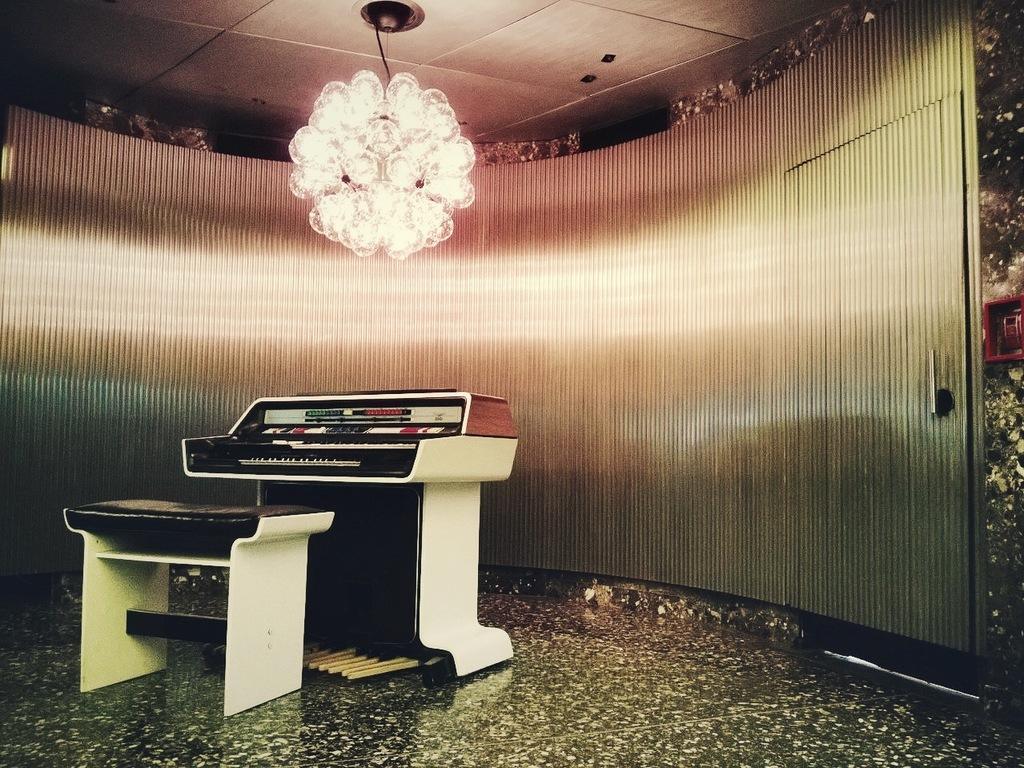How would you summarize this image in a sentence or two? Here we can see a table on the floor, and here is the piano and in front here is the wall, and here is the door, and at above here is the chandelier. 